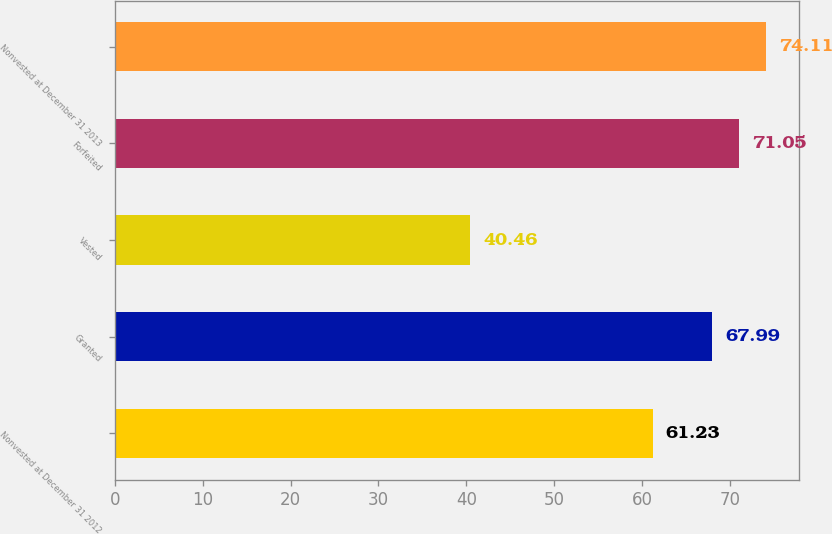<chart> <loc_0><loc_0><loc_500><loc_500><bar_chart><fcel>Nonvested at December 31 2012<fcel>Granted<fcel>Vested<fcel>Forfeited<fcel>Nonvested at December 31 2013<nl><fcel>61.23<fcel>67.99<fcel>40.46<fcel>71.05<fcel>74.11<nl></chart> 